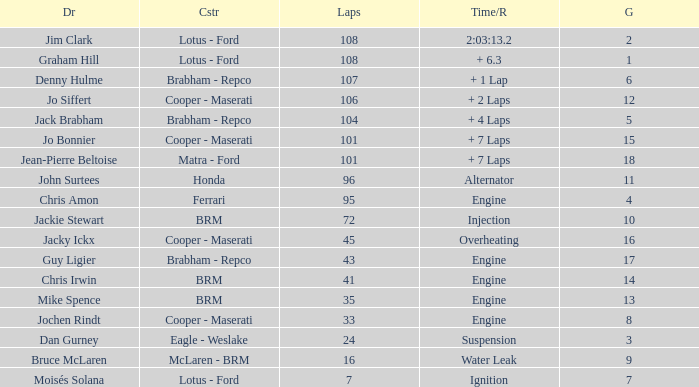What was the grid for suspension time/retired? 3.0. 